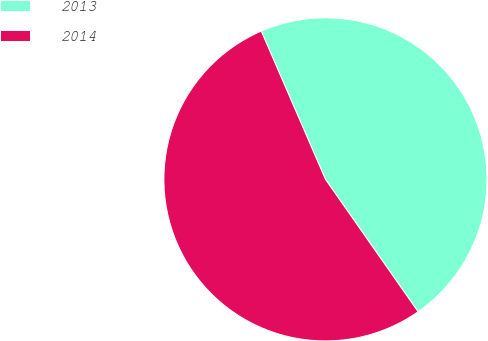Convert chart to OTSL. <chart><loc_0><loc_0><loc_500><loc_500><pie_chart><fcel>2013<fcel>2014<nl><fcel>46.79%<fcel>53.21%<nl></chart> 